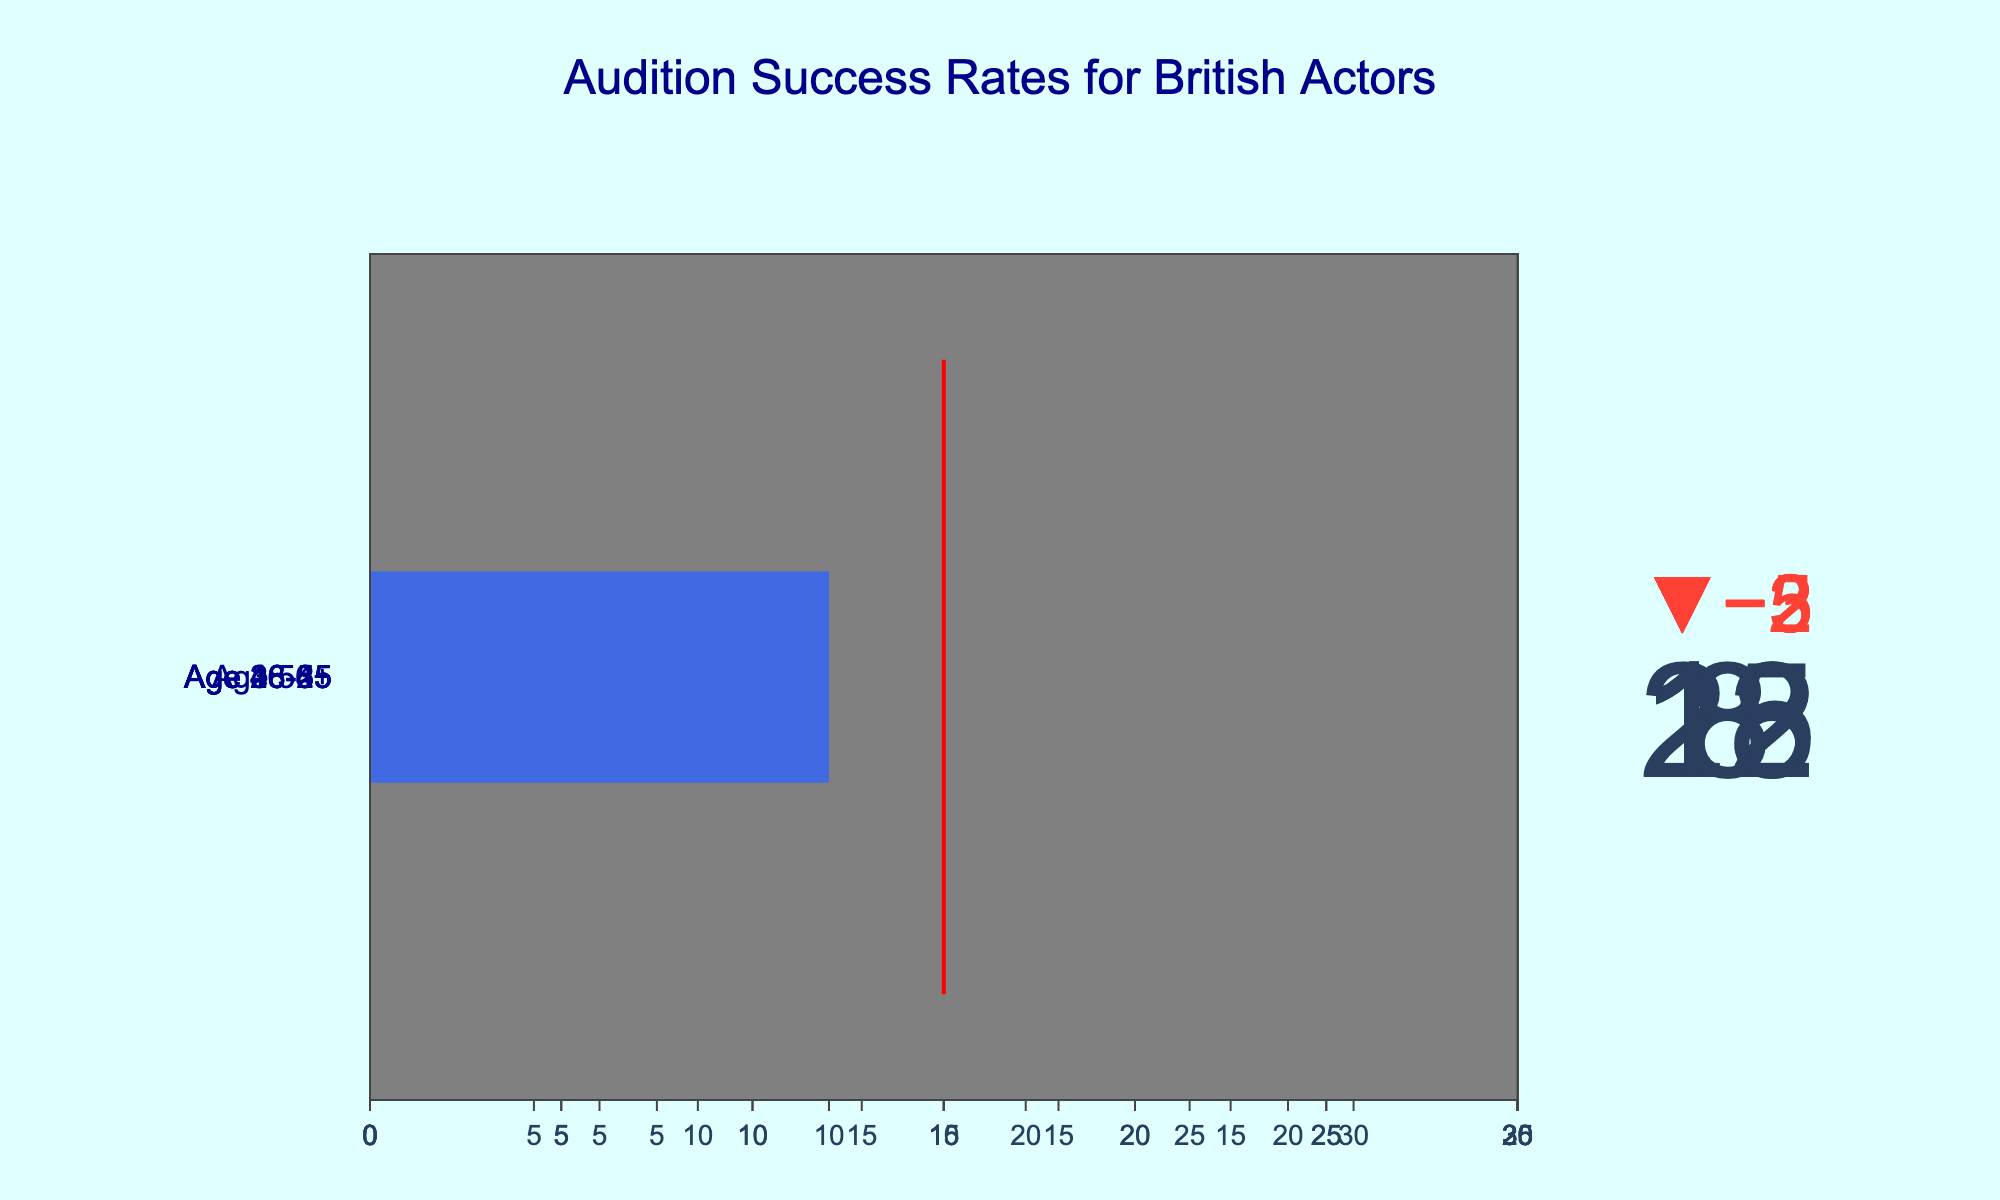What is the actual success rate for actors aged 26-35? The actual success rate is the value specified under the "Actual" column for the age group 26-35. In this case, it is 22.
Answer: 22 What is the target success rate for actors aged 46-55? The target success rate is specified under the "Target" column for the age group 46-55. In this case, it is 15.
Answer: 15 Which age group has the highest actual success rate? Comparing the "Actual" column across all age groups, the age group 26-35 has the highest success rate of 22.
Answer: 26-35 Which age group is furthest from meeting its target success rate? The difference between actual and target success rate is largest for the age group 18-25 (Target: 20, Actual: 15, Difference: 5).
Answer: 18-25 How much lower is the actual success rate for actors aged 56+ compared to their target? Subtract the actual value from the target value for the age group 56+ (Target: 10, Actual: 8). The difference is 2.
Answer: 2 What's the average target success rate across all age groups? Sum of all the target success rates divided by the number of age groups (20 + 25 + 20 + 15 + 10) / 5 gives 90 / 5, which equals 18.
Answer: 18 Do any age groups meet or exceed their target success rates? Check if the actual success rate for any age group is greater than or equal to the target. None of the age groups meet or exceed their target.
Answer: No Which age group has the smallest gap between actual and target success rates? Calculate the difference between actual and target for each group and find the smallest. The age group 36-45 has the smallest difference of 2 (Target: 20, Actual: 18).
Answer: 36-45 How much greater is the actual success rate for actors aged 26-35 compared to those aged 56+? Subtract the actual rate for the age group 56+ from the actual rate for the age group 26-35 (22 - 8). The difference is 14.
Answer: 14 What is the overall trend in audition success rates as actors age? By observing the actual success rates across increasing age groups (18-25: 15, 26-35: 22, 36-45: 18, 46-55: 12, 56+: 8), there is a general decline in success rates as age increases.
Answer: Declining 